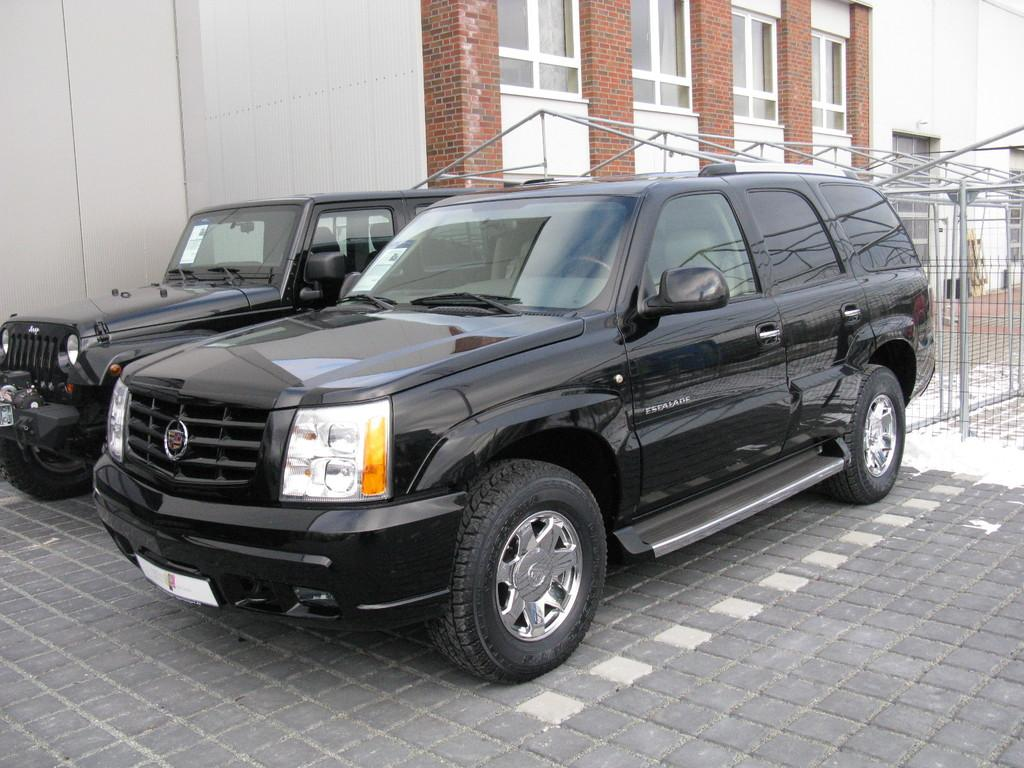What type of vehicles are in the foreground of the image? There are two black cars in the foreground of the image. Where are the cars located? The cars are on the ground. What can be seen in the background of the image? There is a building and a construction site with rods in the background of the image. How many crates are being pulled by the cars in the image? There are no crates present in the image, and the cars are not pulling anything. 